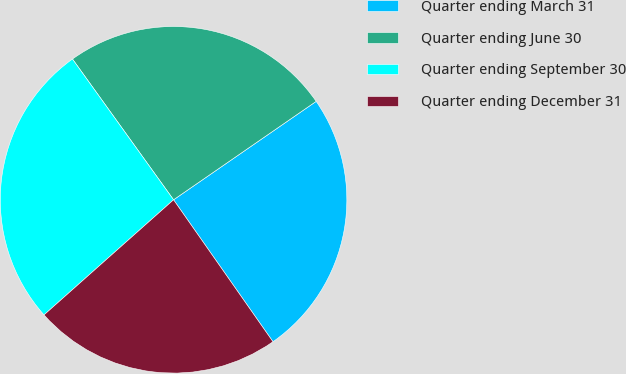Convert chart to OTSL. <chart><loc_0><loc_0><loc_500><loc_500><pie_chart><fcel>Quarter ending March 31<fcel>Quarter ending June 30<fcel>Quarter ending September 30<fcel>Quarter ending December 31<nl><fcel>24.89%<fcel>25.3%<fcel>26.65%<fcel>23.16%<nl></chart> 